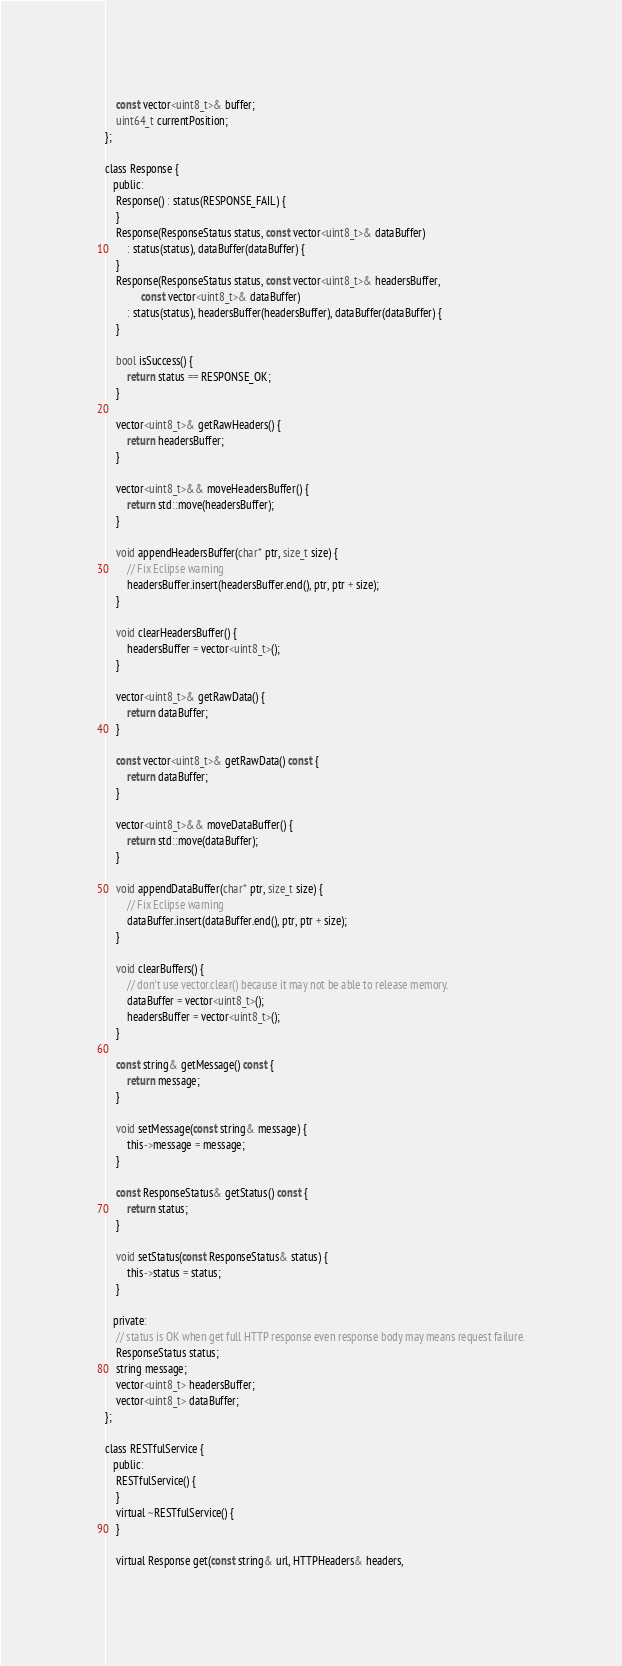Convert code to text. <code><loc_0><loc_0><loc_500><loc_500><_C_>    const vector<uint8_t>& buffer;
    uint64_t currentPosition;
};

class Response {
   public:
    Response() : status(RESPONSE_FAIL) {
    }
    Response(ResponseStatus status, const vector<uint8_t>& dataBuffer)
        : status(status), dataBuffer(dataBuffer) {
    }
    Response(ResponseStatus status, const vector<uint8_t>& headersBuffer,
             const vector<uint8_t>& dataBuffer)
        : status(status), headersBuffer(headersBuffer), dataBuffer(dataBuffer) {
    }

    bool isSuccess() {
        return status == RESPONSE_OK;
    }

    vector<uint8_t>& getRawHeaders() {
        return headersBuffer;
    }

    vector<uint8_t>&& moveHeadersBuffer() {
        return std::move(headersBuffer);
    }

    void appendHeadersBuffer(char* ptr, size_t size) {
        // Fix Eclipse warning
        headersBuffer.insert(headersBuffer.end(), ptr, ptr + size);
    }

    void clearHeadersBuffer() {
        headersBuffer = vector<uint8_t>();
    }

    vector<uint8_t>& getRawData() {
        return dataBuffer;
    }

    const vector<uint8_t>& getRawData() const {
        return dataBuffer;
    }

    vector<uint8_t>&& moveDataBuffer() {
        return std::move(dataBuffer);
    }

    void appendDataBuffer(char* ptr, size_t size) {
        // Fix Eclipse warning
        dataBuffer.insert(dataBuffer.end(), ptr, ptr + size);
    }

    void clearBuffers() {
        // don't use vector.clear() because it may not be able to release memory.
        dataBuffer = vector<uint8_t>();
        headersBuffer = vector<uint8_t>();
    }

    const string& getMessage() const {
        return message;
    }

    void setMessage(const string& message) {
        this->message = message;
    }

    const ResponseStatus& getStatus() const {
        return status;
    }

    void setStatus(const ResponseStatus& status) {
        this->status = status;
    }

   private:
    // status is OK when get full HTTP response even response body may means request failure.
    ResponseStatus status;
    string message;
    vector<uint8_t> headersBuffer;
    vector<uint8_t> dataBuffer;
};

class RESTfulService {
   public:
    RESTfulService() {
    }
    virtual ~RESTfulService() {
    }

    virtual Response get(const string& url, HTTPHeaders& headers,</code> 